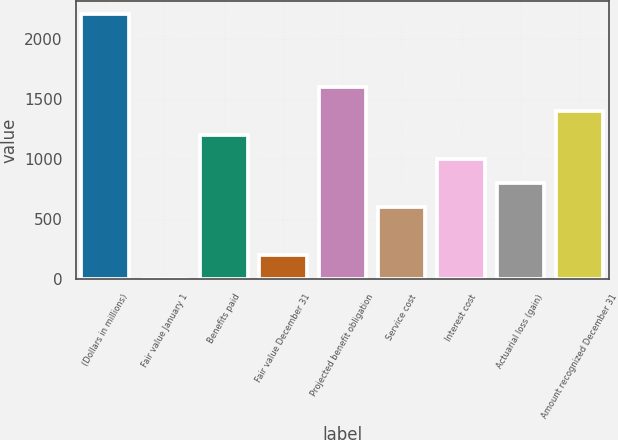Convert chart to OTSL. <chart><loc_0><loc_0><loc_500><loc_500><bar_chart><fcel>(Dollars in millions)<fcel>Fair value January 1<fcel>Benefits paid<fcel>Fair value December 31<fcel>Projected benefit obligation<fcel>Service cost<fcel>Interest cost<fcel>Actuarial loss (gain)<fcel>Amount recognized December 31<nl><fcel>2208.6<fcel>2<fcel>1205.6<fcel>202.6<fcel>1606.8<fcel>603.8<fcel>1005<fcel>804.4<fcel>1406.2<nl></chart> 